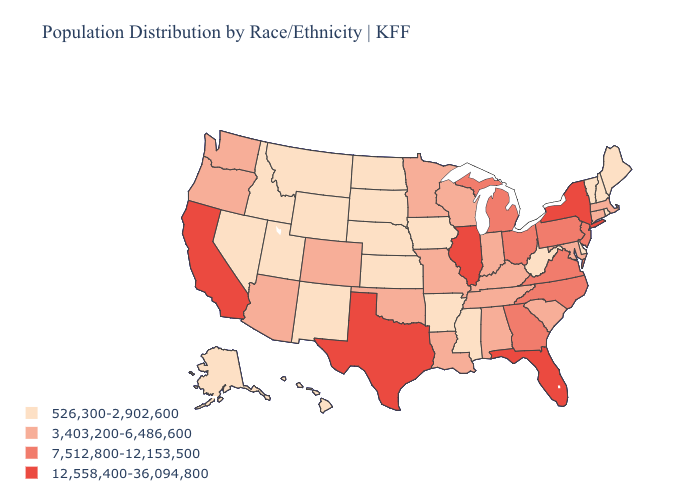Does West Virginia have the lowest value in the South?
Short answer required. Yes. Does Hawaii have a lower value than Wyoming?
Write a very short answer. No. What is the highest value in states that border New Mexico?
Be succinct. 12,558,400-36,094,800. Which states have the lowest value in the MidWest?
Keep it brief. Iowa, Kansas, Nebraska, North Dakota, South Dakota. Does South Dakota have the lowest value in the USA?
Write a very short answer. Yes. What is the lowest value in the USA?
Be succinct. 526,300-2,902,600. What is the lowest value in states that border Arkansas?
Short answer required. 526,300-2,902,600. What is the value of Arizona?
Give a very brief answer. 3,403,200-6,486,600. Does Wisconsin have the same value as Florida?
Answer briefly. No. Does Ohio have a lower value than Illinois?
Concise answer only. Yes. Is the legend a continuous bar?
Quick response, please. No. Does Illinois have the same value as Delaware?
Write a very short answer. No. Which states have the lowest value in the West?
Keep it brief. Alaska, Hawaii, Idaho, Montana, Nevada, New Mexico, Utah, Wyoming. What is the lowest value in the USA?
Write a very short answer. 526,300-2,902,600. What is the value of Nebraska?
Give a very brief answer. 526,300-2,902,600. 